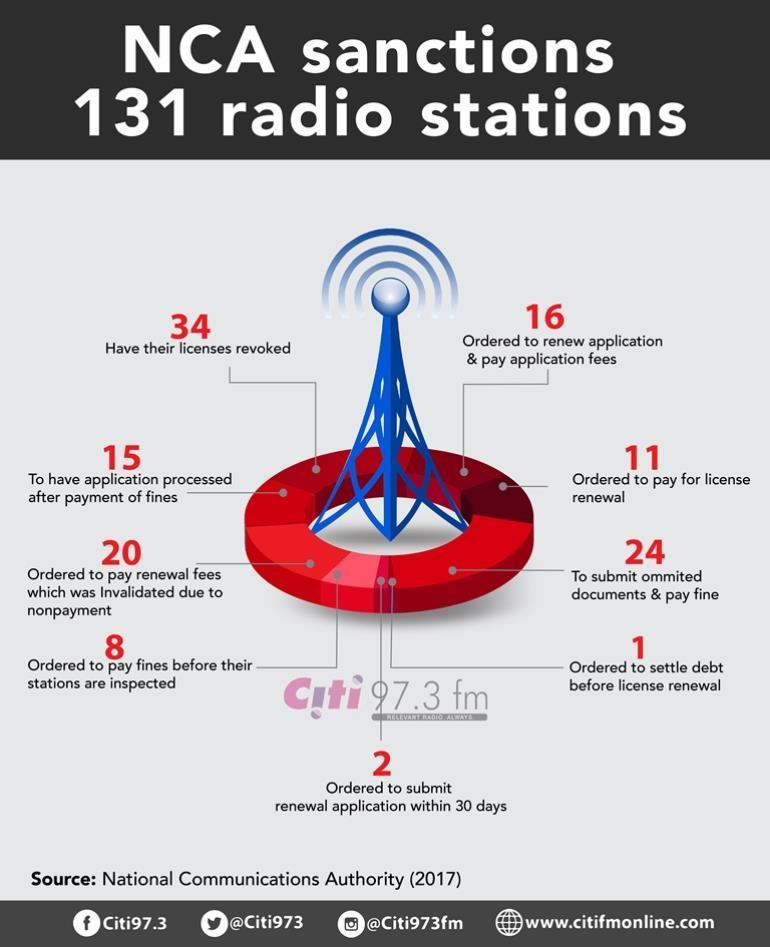How many radio stations were ordered to renew application & pay application fees by NCA in 2017?
Answer the question with a short phrase. 16 How many radio stations were ordered to pay for license by NCA in 2017? 11 How many radio stations were ordered to settle debt before license renewal by NCA in 2017? 1 How many radio stations have to submit omitted documents & pay fine as per the NCA in 2017? 24 How many radio stations have their license revoked by NCA in 2017? 34 